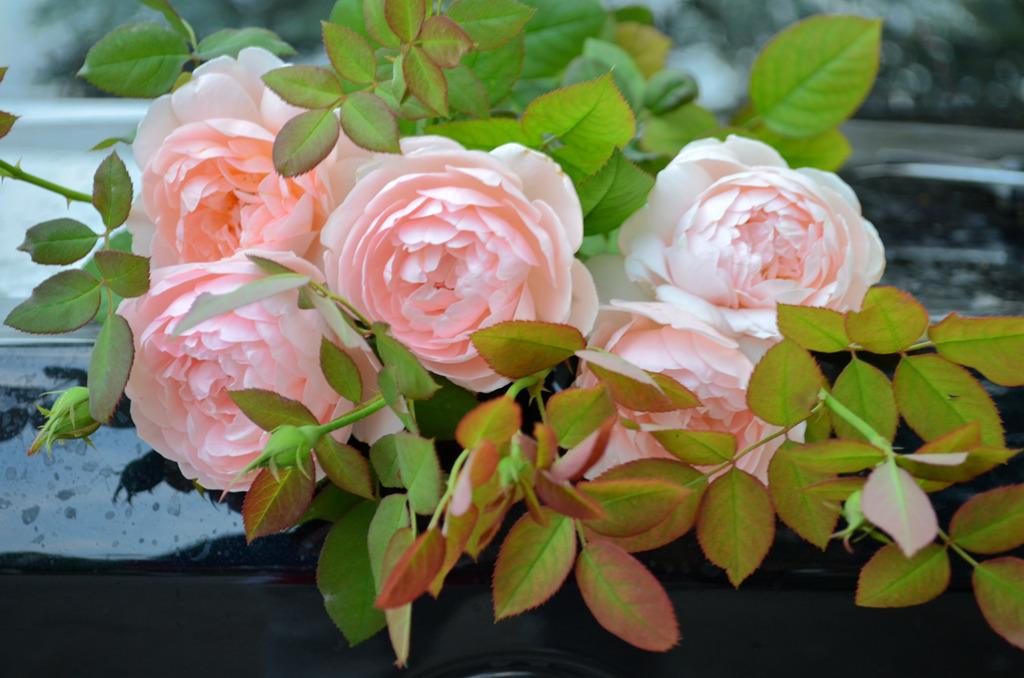What type of plants can be seen in the image? There are flowers in the image. What color are the flowers? The flowers are pink in color. What else can be seen in the image besides the flowers? There are leaves in the image. What color are the leaves? The leaves are green in color. What flavor of oil is being used to water the flowers in the image? There is no oil present in the image, and the flowers are not being watered. 